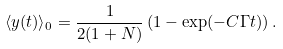<formula> <loc_0><loc_0><loc_500><loc_500>\langle y ( t ) \rangle _ { 0 } = \frac { 1 } { 2 ( 1 + N ) } \left ( 1 - \exp ( - C \Gamma t ) \right ) .</formula> 